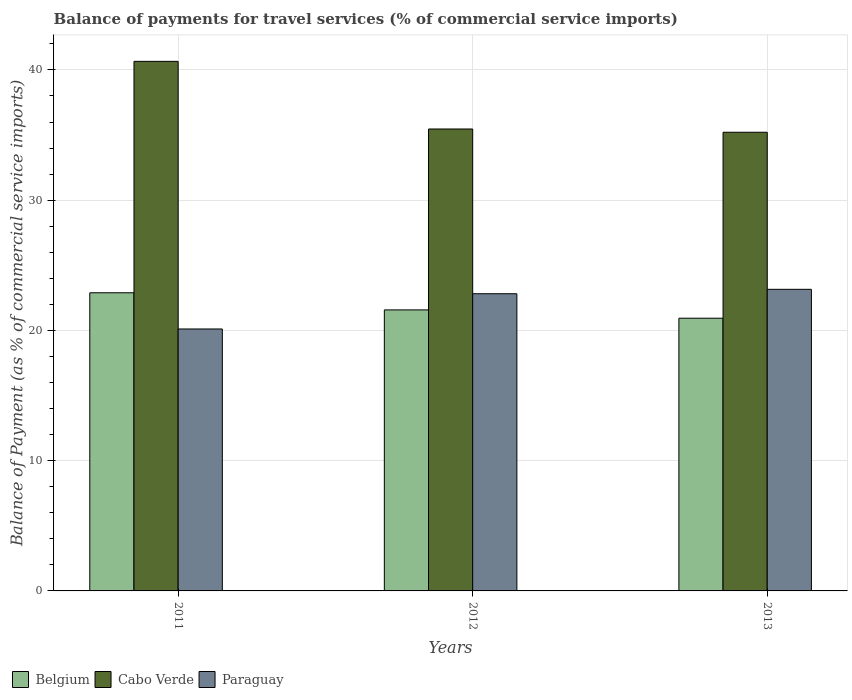How many different coloured bars are there?
Keep it short and to the point. 3. How many groups of bars are there?
Give a very brief answer. 3. Are the number of bars on each tick of the X-axis equal?
Your response must be concise. Yes. How many bars are there on the 1st tick from the left?
Make the answer very short. 3. What is the label of the 3rd group of bars from the left?
Offer a very short reply. 2013. In how many cases, is the number of bars for a given year not equal to the number of legend labels?
Make the answer very short. 0. What is the balance of payments for travel services in Cabo Verde in 2012?
Offer a terse response. 35.47. Across all years, what is the maximum balance of payments for travel services in Cabo Verde?
Offer a terse response. 40.66. Across all years, what is the minimum balance of payments for travel services in Cabo Verde?
Make the answer very short. 35.21. In which year was the balance of payments for travel services in Cabo Verde maximum?
Make the answer very short. 2011. What is the total balance of payments for travel services in Cabo Verde in the graph?
Ensure brevity in your answer.  111.34. What is the difference between the balance of payments for travel services in Belgium in 2011 and that in 2013?
Offer a very short reply. 1.95. What is the difference between the balance of payments for travel services in Cabo Verde in 2011 and the balance of payments for travel services in Belgium in 2012?
Offer a terse response. 19.08. What is the average balance of payments for travel services in Belgium per year?
Provide a short and direct response. 21.8. In the year 2011, what is the difference between the balance of payments for travel services in Cabo Verde and balance of payments for travel services in Paraguay?
Offer a terse response. 20.55. In how many years, is the balance of payments for travel services in Cabo Verde greater than 24 %?
Give a very brief answer. 3. What is the ratio of the balance of payments for travel services in Paraguay in 2011 to that in 2013?
Keep it short and to the point. 0.87. Is the balance of payments for travel services in Paraguay in 2011 less than that in 2012?
Your answer should be compact. Yes. What is the difference between the highest and the second highest balance of payments for travel services in Cabo Verde?
Your response must be concise. 5.19. What is the difference between the highest and the lowest balance of payments for travel services in Cabo Verde?
Provide a succinct answer. 5.44. Is the sum of the balance of payments for travel services in Belgium in 2011 and 2013 greater than the maximum balance of payments for travel services in Paraguay across all years?
Offer a very short reply. Yes. What does the 3rd bar from the left in 2013 represents?
Offer a very short reply. Paraguay. What does the 2nd bar from the right in 2012 represents?
Your answer should be compact. Cabo Verde. Is it the case that in every year, the sum of the balance of payments for travel services in Paraguay and balance of payments for travel services in Belgium is greater than the balance of payments for travel services in Cabo Verde?
Your answer should be compact. Yes. How many bars are there?
Make the answer very short. 9. Are all the bars in the graph horizontal?
Make the answer very short. No. What is the difference between two consecutive major ticks on the Y-axis?
Make the answer very short. 10. Are the values on the major ticks of Y-axis written in scientific E-notation?
Provide a succinct answer. No. Does the graph contain any zero values?
Provide a short and direct response. No. How are the legend labels stacked?
Make the answer very short. Horizontal. What is the title of the graph?
Make the answer very short. Balance of payments for travel services (% of commercial service imports). Does "Mozambique" appear as one of the legend labels in the graph?
Keep it short and to the point. No. What is the label or title of the Y-axis?
Your response must be concise. Balance of Payment (as % of commercial service imports). What is the Balance of Payment (as % of commercial service imports) in Belgium in 2011?
Ensure brevity in your answer.  22.89. What is the Balance of Payment (as % of commercial service imports) of Cabo Verde in 2011?
Provide a short and direct response. 40.66. What is the Balance of Payment (as % of commercial service imports) of Paraguay in 2011?
Ensure brevity in your answer.  20.11. What is the Balance of Payment (as % of commercial service imports) of Belgium in 2012?
Keep it short and to the point. 21.58. What is the Balance of Payment (as % of commercial service imports) in Cabo Verde in 2012?
Offer a very short reply. 35.47. What is the Balance of Payment (as % of commercial service imports) in Paraguay in 2012?
Keep it short and to the point. 22.82. What is the Balance of Payment (as % of commercial service imports) of Belgium in 2013?
Your answer should be compact. 20.94. What is the Balance of Payment (as % of commercial service imports) of Cabo Verde in 2013?
Provide a succinct answer. 35.21. What is the Balance of Payment (as % of commercial service imports) of Paraguay in 2013?
Ensure brevity in your answer.  23.16. Across all years, what is the maximum Balance of Payment (as % of commercial service imports) of Belgium?
Provide a succinct answer. 22.89. Across all years, what is the maximum Balance of Payment (as % of commercial service imports) of Cabo Verde?
Keep it short and to the point. 40.66. Across all years, what is the maximum Balance of Payment (as % of commercial service imports) in Paraguay?
Give a very brief answer. 23.16. Across all years, what is the minimum Balance of Payment (as % of commercial service imports) of Belgium?
Ensure brevity in your answer.  20.94. Across all years, what is the minimum Balance of Payment (as % of commercial service imports) of Cabo Verde?
Provide a succinct answer. 35.21. Across all years, what is the minimum Balance of Payment (as % of commercial service imports) of Paraguay?
Provide a short and direct response. 20.11. What is the total Balance of Payment (as % of commercial service imports) in Belgium in the graph?
Your answer should be compact. 65.41. What is the total Balance of Payment (as % of commercial service imports) in Cabo Verde in the graph?
Provide a succinct answer. 111.34. What is the total Balance of Payment (as % of commercial service imports) in Paraguay in the graph?
Offer a terse response. 66.09. What is the difference between the Balance of Payment (as % of commercial service imports) of Belgium in 2011 and that in 2012?
Your answer should be very brief. 1.32. What is the difference between the Balance of Payment (as % of commercial service imports) of Cabo Verde in 2011 and that in 2012?
Offer a very short reply. 5.19. What is the difference between the Balance of Payment (as % of commercial service imports) of Paraguay in 2011 and that in 2012?
Your answer should be compact. -2.71. What is the difference between the Balance of Payment (as % of commercial service imports) of Belgium in 2011 and that in 2013?
Offer a terse response. 1.95. What is the difference between the Balance of Payment (as % of commercial service imports) in Cabo Verde in 2011 and that in 2013?
Provide a short and direct response. 5.44. What is the difference between the Balance of Payment (as % of commercial service imports) in Paraguay in 2011 and that in 2013?
Provide a short and direct response. -3.04. What is the difference between the Balance of Payment (as % of commercial service imports) of Belgium in 2012 and that in 2013?
Offer a terse response. 0.64. What is the difference between the Balance of Payment (as % of commercial service imports) in Cabo Verde in 2012 and that in 2013?
Give a very brief answer. 0.25. What is the difference between the Balance of Payment (as % of commercial service imports) of Paraguay in 2012 and that in 2013?
Keep it short and to the point. -0.34. What is the difference between the Balance of Payment (as % of commercial service imports) in Belgium in 2011 and the Balance of Payment (as % of commercial service imports) in Cabo Verde in 2012?
Ensure brevity in your answer.  -12.57. What is the difference between the Balance of Payment (as % of commercial service imports) of Belgium in 2011 and the Balance of Payment (as % of commercial service imports) of Paraguay in 2012?
Your answer should be very brief. 0.07. What is the difference between the Balance of Payment (as % of commercial service imports) in Cabo Verde in 2011 and the Balance of Payment (as % of commercial service imports) in Paraguay in 2012?
Offer a terse response. 17.84. What is the difference between the Balance of Payment (as % of commercial service imports) in Belgium in 2011 and the Balance of Payment (as % of commercial service imports) in Cabo Verde in 2013?
Make the answer very short. -12.32. What is the difference between the Balance of Payment (as % of commercial service imports) in Belgium in 2011 and the Balance of Payment (as % of commercial service imports) in Paraguay in 2013?
Your answer should be compact. -0.27. What is the difference between the Balance of Payment (as % of commercial service imports) of Cabo Verde in 2011 and the Balance of Payment (as % of commercial service imports) of Paraguay in 2013?
Offer a very short reply. 17.5. What is the difference between the Balance of Payment (as % of commercial service imports) of Belgium in 2012 and the Balance of Payment (as % of commercial service imports) of Cabo Verde in 2013?
Your answer should be compact. -13.64. What is the difference between the Balance of Payment (as % of commercial service imports) of Belgium in 2012 and the Balance of Payment (as % of commercial service imports) of Paraguay in 2013?
Your response must be concise. -1.58. What is the difference between the Balance of Payment (as % of commercial service imports) in Cabo Verde in 2012 and the Balance of Payment (as % of commercial service imports) in Paraguay in 2013?
Your response must be concise. 12.31. What is the average Balance of Payment (as % of commercial service imports) of Belgium per year?
Offer a very short reply. 21.8. What is the average Balance of Payment (as % of commercial service imports) of Cabo Verde per year?
Offer a very short reply. 37.11. What is the average Balance of Payment (as % of commercial service imports) in Paraguay per year?
Keep it short and to the point. 22.03. In the year 2011, what is the difference between the Balance of Payment (as % of commercial service imports) in Belgium and Balance of Payment (as % of commercial service imports) in Cabo Verde?
Give a very brief answer. -17.77. In the year 2011, what is the difference between the Balance of Payment (as % of commercial service imports) in Belgium and Balance of Payment (as % of commercial service imports) in Paraguay?
Keep it short and to the point. 2.78. In the year 2011, what is the difference between the Balance of Payment (as % of commercial service imports) of Cabo Verde and Balance of Payment (as % of commercial service imports) of Paraguay?
Ensure brevity in your answer.  20.55. In the year 2012, what is the difference between the Balance of Payment (as % of commercial service imports) in Belgium and Balance of Payment (as % of commercial service imports) in Cabo Verde?
Provide a succinct answer. -13.89. In the year 2012, what is the difference between the Balance of Payment (as % of commercial service imports) in Belgium and Balance of Payment (as % of commercial service imports) in Paraguay?
Your answer should be very brief. -1.24. In the year 2012, what is the difference between the Balance of Payment (as % of commercial service imports) in Cabo Verde and Balance of Payment (as % of commercial service imports) in Paraguay?
Your answer should be compact. 12.65. In the year 2013, what is the difference between the Balance of Payment (as % of commercial service imports) in Belgium and Balance of Payment (as % of commercial service imports) in Cabo Verde?
Keep it short and to the point. -14.28. In the year 2013, what is the difference between the Balance of Payment (as % of commercial service imports) of Belgium and Balance of Payment (as % of commercial service imports) of Paraguay?
Your answer should be compact. -2.22. In the year 2013, what is the difference between the Balance of Payment (as % of commercial service imports) of Cabo Verde and Balance of Payment (as % of commercial service imports) of Paraguay?
Keep it short and to the point. 12.06. What is the ratio of the Balance of Payment (as % of commercial service imports) of Belgium in 2011 to that in 2012?
Your response must be concise. 1.06. What is the ratio of the Balance of Payment (as % of commercial service imports) in Cabo Verde in 2011 to that in 2012?
Make the answer very short. 1.15. What is the ratio of the Balance of Payment (as % of commercial service imports) of Paraguay in 2011 to that in 2012?
Your answer should be very brief. 0.88. What is the ratio of the Balance of Payment (as % of commercial service imports) of Belgium in 2011 to that in 2013?
Your response must be concise. 1.09. What is the ratio of the Balance of Payment (as % of commercial service imports) of Cabo Verde in 2011 to that in 2013?
Provide a short and direct response. 1.15. What is the ratio of the Balance of Payment (as % of commercial service imports) of Paraguay in 2011 to that in 2013?
Offer a very short reply. 0.87. What is the ratio of the Balance of Payment (as % of commercial service imports) in Belgium in 2012 to that in 2013?
Your answer should be very brief. 1.03. What is the ratio of the Balance of Payment (as % of commercial service imports) of Cabo Verde in 2012 to that in 2013?
Your response must be concise. 1.01. What is the difference between the highest and the second highest Balance of Payment (as % of commercial service imports) of Belgium?
Keep it short and to the point. 1.32. What is the difference between the highest and the second highest Balance of Payment (as % of commercial service imports) in Cabo Verde?
Provide a short and direct response. 5.19. What is the difference between the highest and the second highest Balance of Payment (as % of commercial service imports) of Paraguay?
Your answer should be very brief. 0.34. What is the difference between the highest and the lowest Balance of Payment (as % of commercial service imports) of Belgium?
Provide a short and direct response. 1.95. What is the difference between the highest and the lowest Balance of Payment (as % of commercial service imports) in Cabo Verde?
Offer a very short reply. 5.44. What is the difference between the highest and the lowest Balance of Payment (as % of commercial service imports) in Paraguay?
Provide a short and direct response. 3.04. 